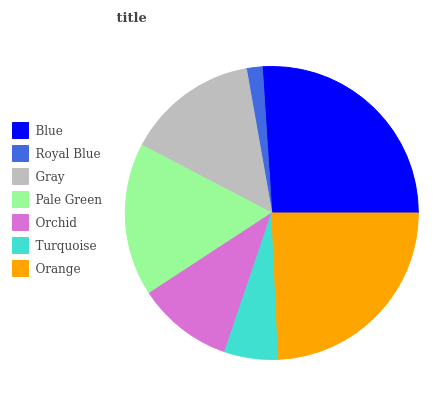Is Royal Blue the minimum?
Answer yes or no. Yes. Is Blue the maximum?
Answer yes or no. Yes. Is Gray the minimum?
Answer yes or no. No. Is Gray the maximum?
Answer yes or no. No. Is Gray greater than Royal Blue?
Answer yes or no. Yes. Is Royal Blue less than Gray?
Answer yes or no. Yes. Is Royal Blue greater than Gray?
Answer yes or no. No. Is Gray less than Royal Blue?
Answer yes or no. No. Is Gray the high median?
Answer yes or no. Yes. Is Gray the low median?
Answer yes or no. Yes. Is Turquoise the high median?
Answer yes or no. No. Is Pale Green the low median?
Answer yes or no. No. 